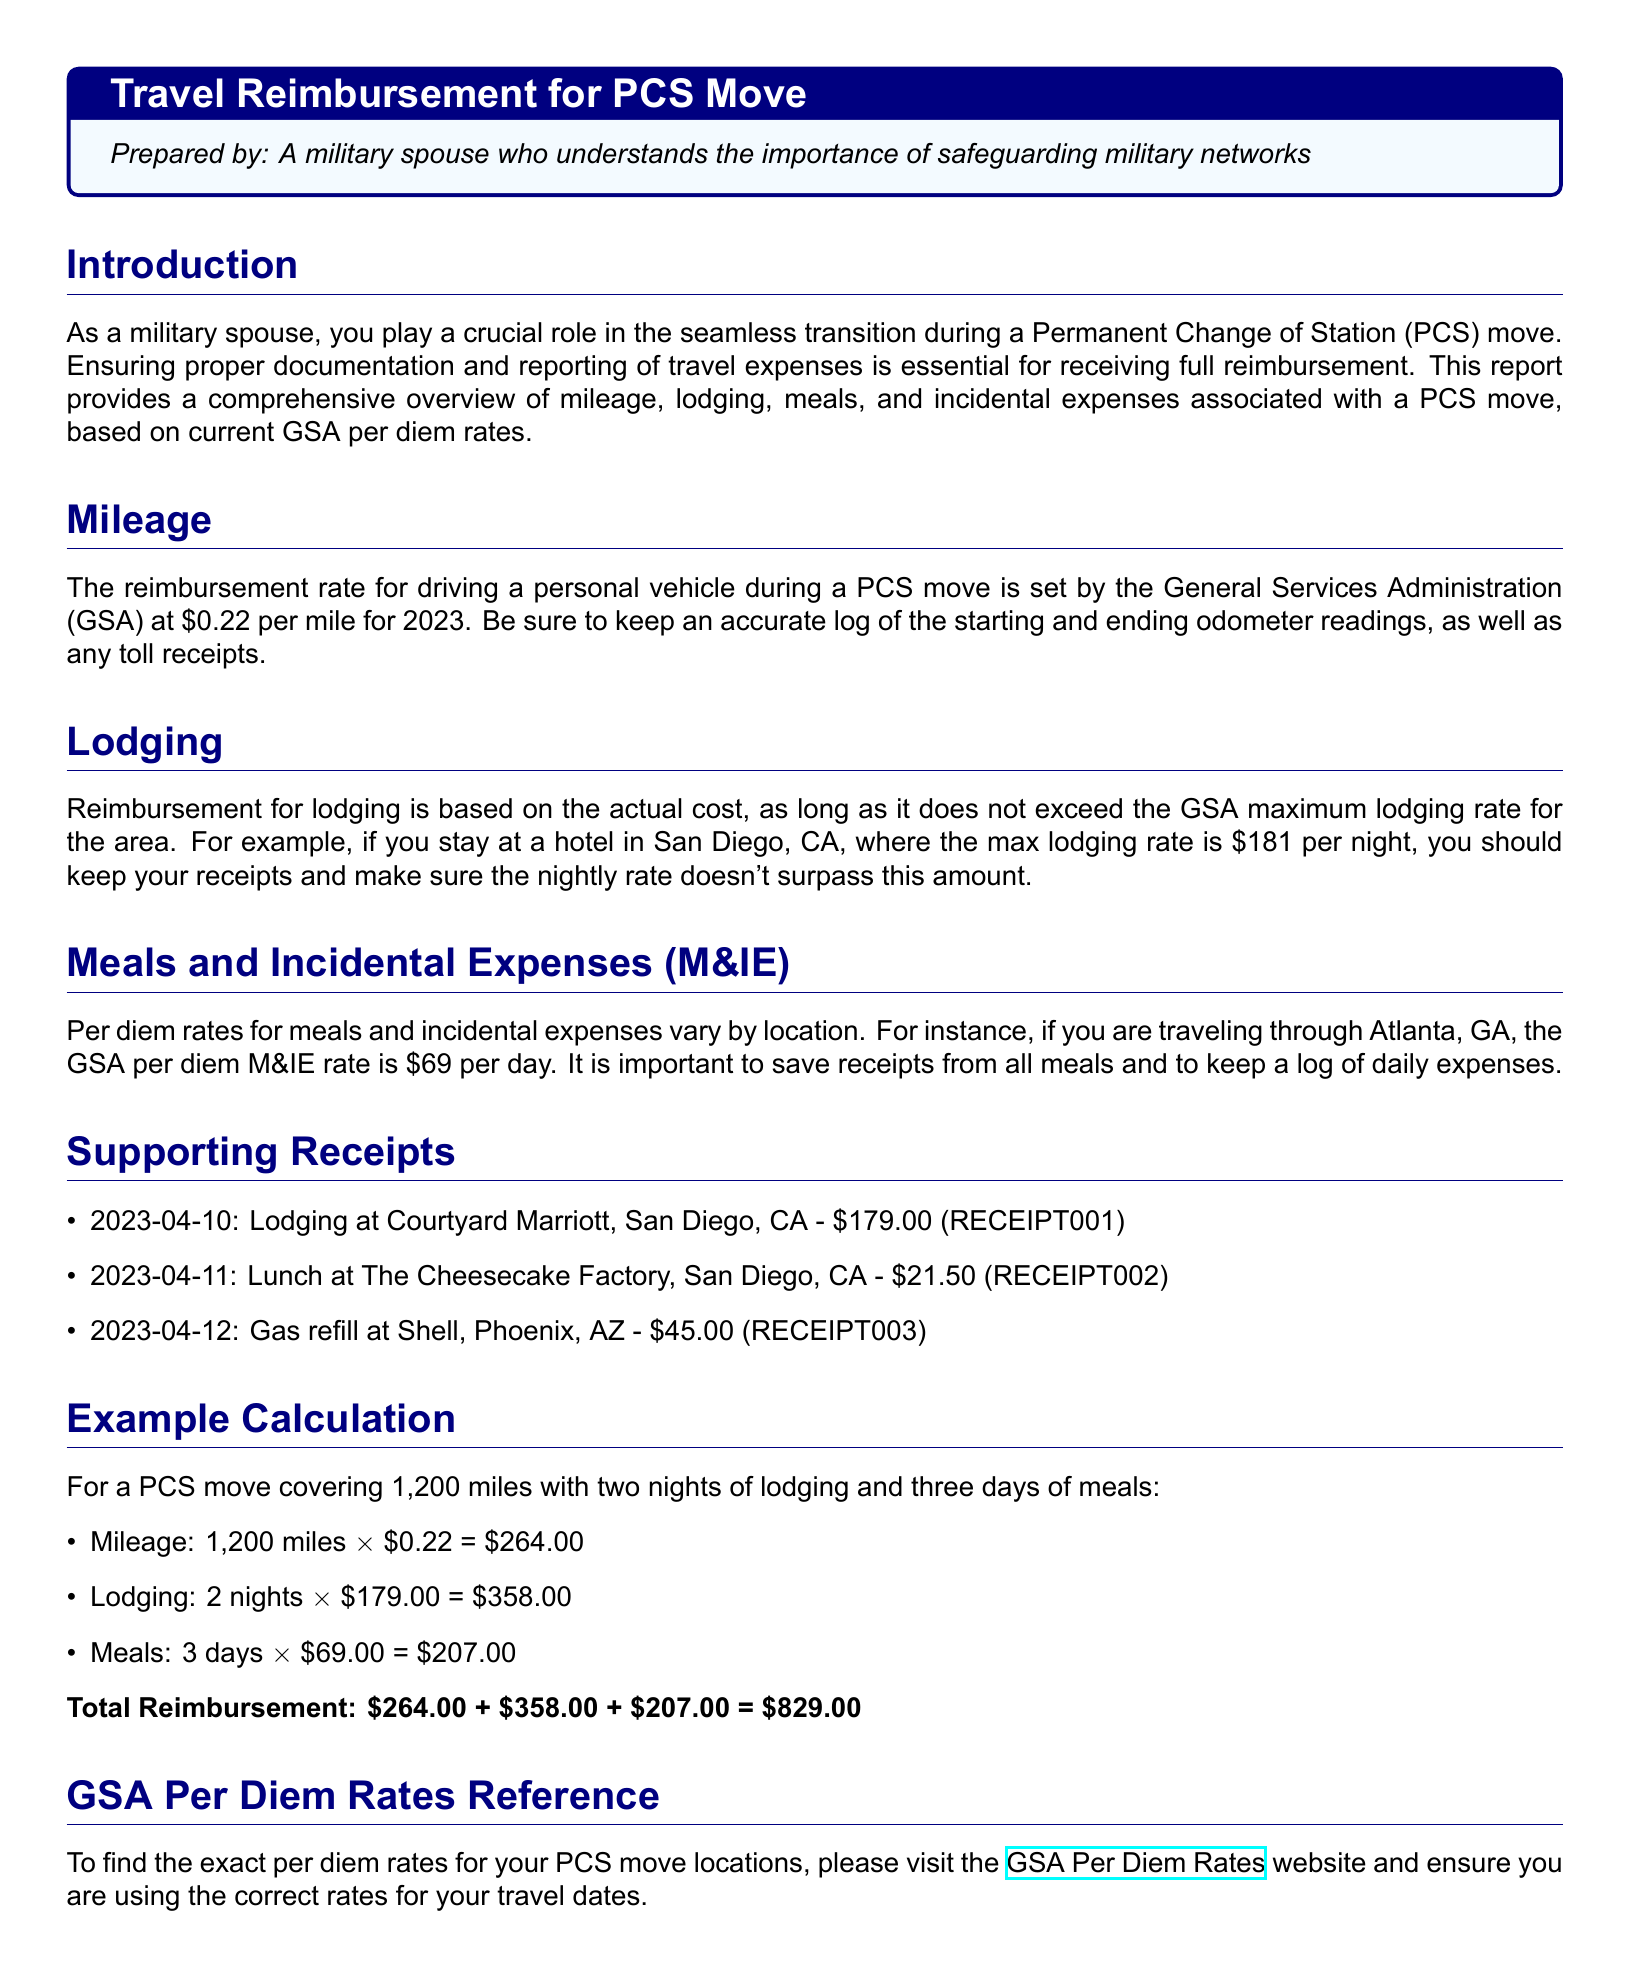what is the reimbursement rate for mileage? The reimbursement rate for driving a personal vehicle during a PCS move is \$0.22 per mile for 2023.
Answer: \$0.22 per mile what is the maximum lodging rate for San Diego, CA? The maximum lodging rate for San Diego, CA is \$181 per night.
Answer: \$181 how many nights of lodging were claimed in the example calculation? In the example calculation, 2 nights of lodging were claimed.
Answer: 2 nights what is the GSA per diem M&IE rate for Atlanta, GA? The GSA per diem M&IE rate for Atlanta, GA is \$69 per day.
Answer: \$69 what is the total reimbursement amount in the example calculation? The total reimbursement amount is calculated by adding the mileage, lodging, and meals expenses in the example section.
Answer: \$829.00 how much was spent on meals in the example calculation? The cost for meals in the example calculation is derived from the GSA per diem rate and the number of days.
Answer: \$207.00 what is the date of the lodging receipt? The date of the lodging receipt (Courtyard Marriott) is provided in the supporting receipts section.
Answer: 2023-04-10 how much was spent on gas refill according to the receipts? The amount spent on gas refill is stated in the supporting receipts section.
Answer: \$45.00 what website is referenced for GSA per diem rates? The document includes a specific URL for finding GSA per diem rates.
Answer: GSA Per Diem Rates网站 